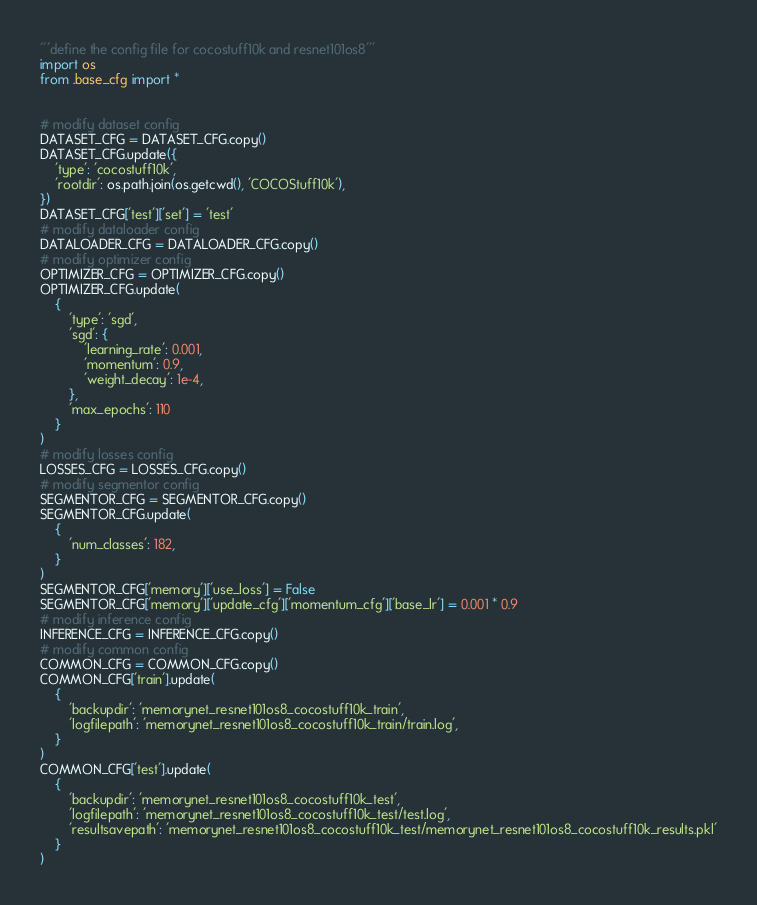<code> <loc_0><loc_0><loc_500><loc_500><_Python_>'''define the config file for cocostuff10k and resnet101os8'''
import os
from .base_cfg import *


# modify dataset config
DATASET_CFG = DATASET_CFG.copy()
DATASET_CFG.update({
    'type': 'cocostuff10k',
    'rootdir': os.path.join(os.getcwd(), 'COCOStuff10k'),
})
DATASET_CFG['test']['set'] = 'test'
# modify dataloader config
DATALOADER_CFG = DATALOADER_CFG.copy()
# modify optimizer config
OPTIMIZER_CFG = OPTIMIZER_CFG.copy()
OPTIMIZER_CFG.update(
    {
        'type': 'sgd',
        'sgd': {
            'learning_rate': 0.001,
            'momentum': 0.9,
            'weight_decay': 1e-4,
        },
        'max_epochs': 110
    }
)
# modify losses config
LOSSES_CFG = LOSSES_CFG.copy()
# modify segmentor config
SEGMENTOR_CFG = SEGMENTOR_CFG.copy()
SEGMENTOR_CFG.update(
    {
        'num_classes': 182,
    }
)
SEGMENTOR_CFG['memory']['use_loss'] = False
SEGMENTOR_CFG['memory']['update_cfg']['momentum_cfg']['base_lr'] = 0.001 * 0.9
# modify inference config
INFERENCE_CFG = INFERENCE_CFG.copy()
# modify common config
COMMON_CFG = COMMON_CFG.copy()
COMMON_CFG['train'].update(
    {
        'backupdir': 'memorynet_resnet101os8_cocostuff10k_train',
        'logfilepath': 'memorynet_resnet101os8_cocostuff10k_train/train.log',
    }
)
COMMON_CFG['test'].update(
    {
        'backupdir': 'memorynet_resnet101os8_cocostuff10k_test',
        'logfilepath': 'memorynet_resnet101os8_cocostuff10k_test/test.log',
        'resultsavepath': 'memorynet_resnet101os8_cocostuff10k_test/memorynet_resnet101os8_cocostuff10k_results.pkl'
    }
)</code> 